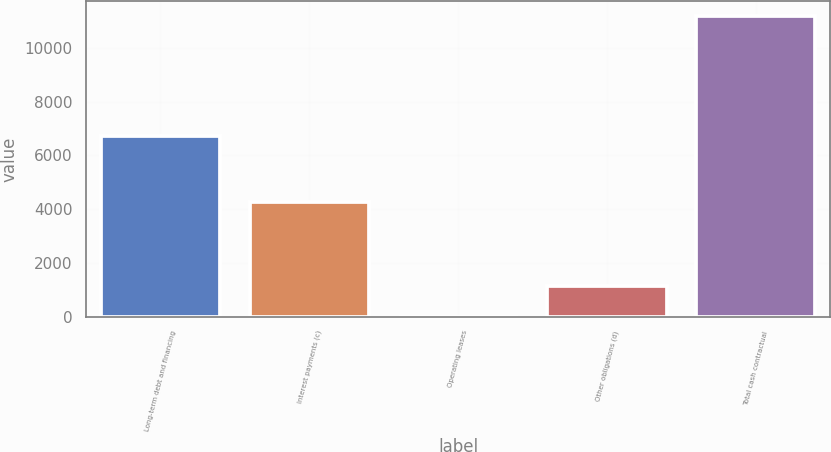Convert chart. <chart><loc_0><loc_0><loc_500><loc_500><bar_chart><fcel>Long-term debt and financing<fcel>Interest payments (c)<fcel>Operating leases<fcel>Other obligations (d)<fcel>Total cash contractual<nl><fcel>6734<fcel>4281<fcel>9<fcel>1127.1<fcel>11190<nl></chart> 